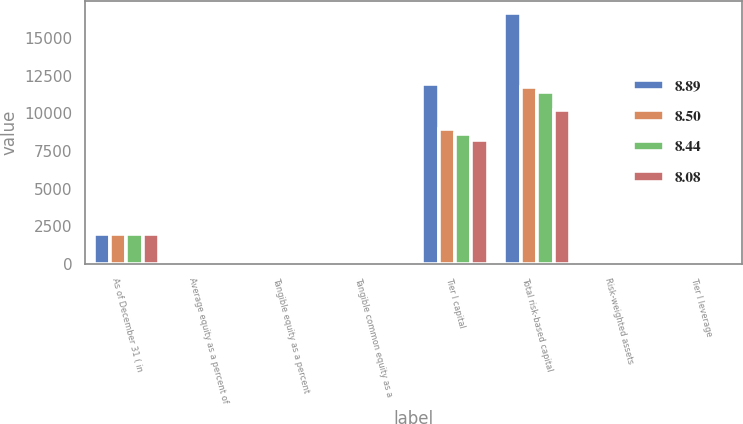Convert chart to OTSL. <chart><loc_0><loc_0><loc_500><loc_500><stacked_bar_chart><ecel><fcel>As of December 31 ( in<fcel>Average equity as a percent of<fcel>Tangible equity as a percent<fcel>Tangible common equity as a<fcel>Tier I capital<fcel>Total risk-based capital<fcel>Risk-weighted assets<fcel>Tier I leverage<nl><fcel>8.89<fcel>2008<fcel>8.78<fcel>7.86<fcel>4.23<fcel>11924<fcel>16646<fcel>9.335<fcel>10.27<nl><fcel>8.5<fcel>2007<fcel>9.35<fcel>6.14<fcel>6.14<fcel>8924<fcel>11733<fcel>9.335<fcel>8.5<nl><fcel>8.44<fcel>2006<fcel>9.32<fcel>7.95<fcel>7.95<fcel>8625<fcel>11385<fcel>9.335<fcel>8.44<nl><fcel>8.08<fcel>2005<fcel>9.06<fcel>7.23<fcel>7.22<fcel>8209<fcel>10240<fcel>9.335<fcel>8.08<nl></chart> 